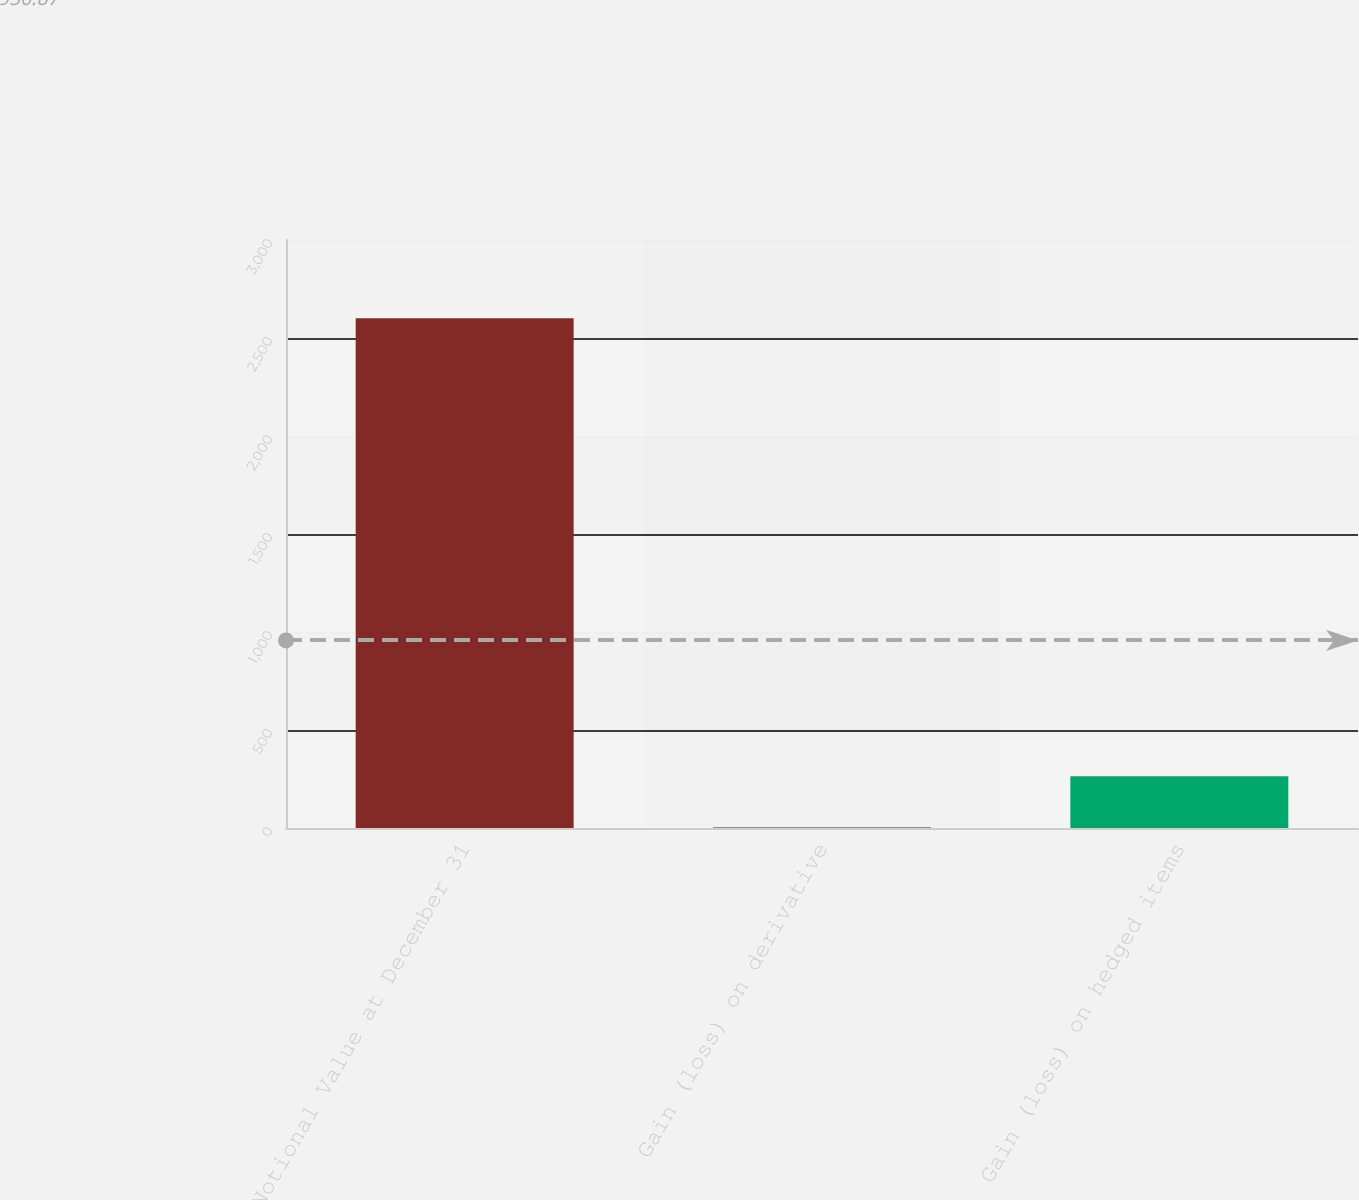<chart> <loc_0><loc_0><loc_500><loc_500><bar_chart><fcel>Notional Value at December 31<fcel>Gain (loss) on derivative<fcel>Gain (loss) on hedged items<nl><fcel>2601<fcel>5<fcel>264.6<nl></chart> 